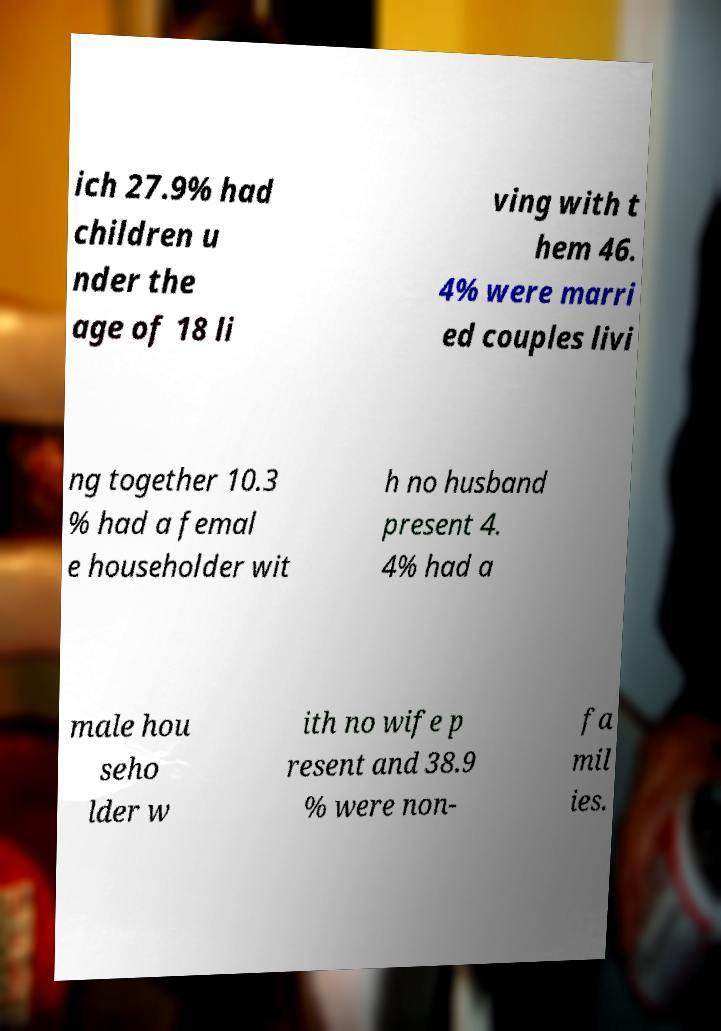Please identify and transcribe the text found in this image. ich 27.9% had children u nder the age of 18 li ving with t hem 46. 4% were marri ed couples livi ng together 10.3 % had a femal e householder wit h no husband present 4. 4% had a male hou seho lder w ith no wife p resent and 38.9 % were non- fa mil ies. 